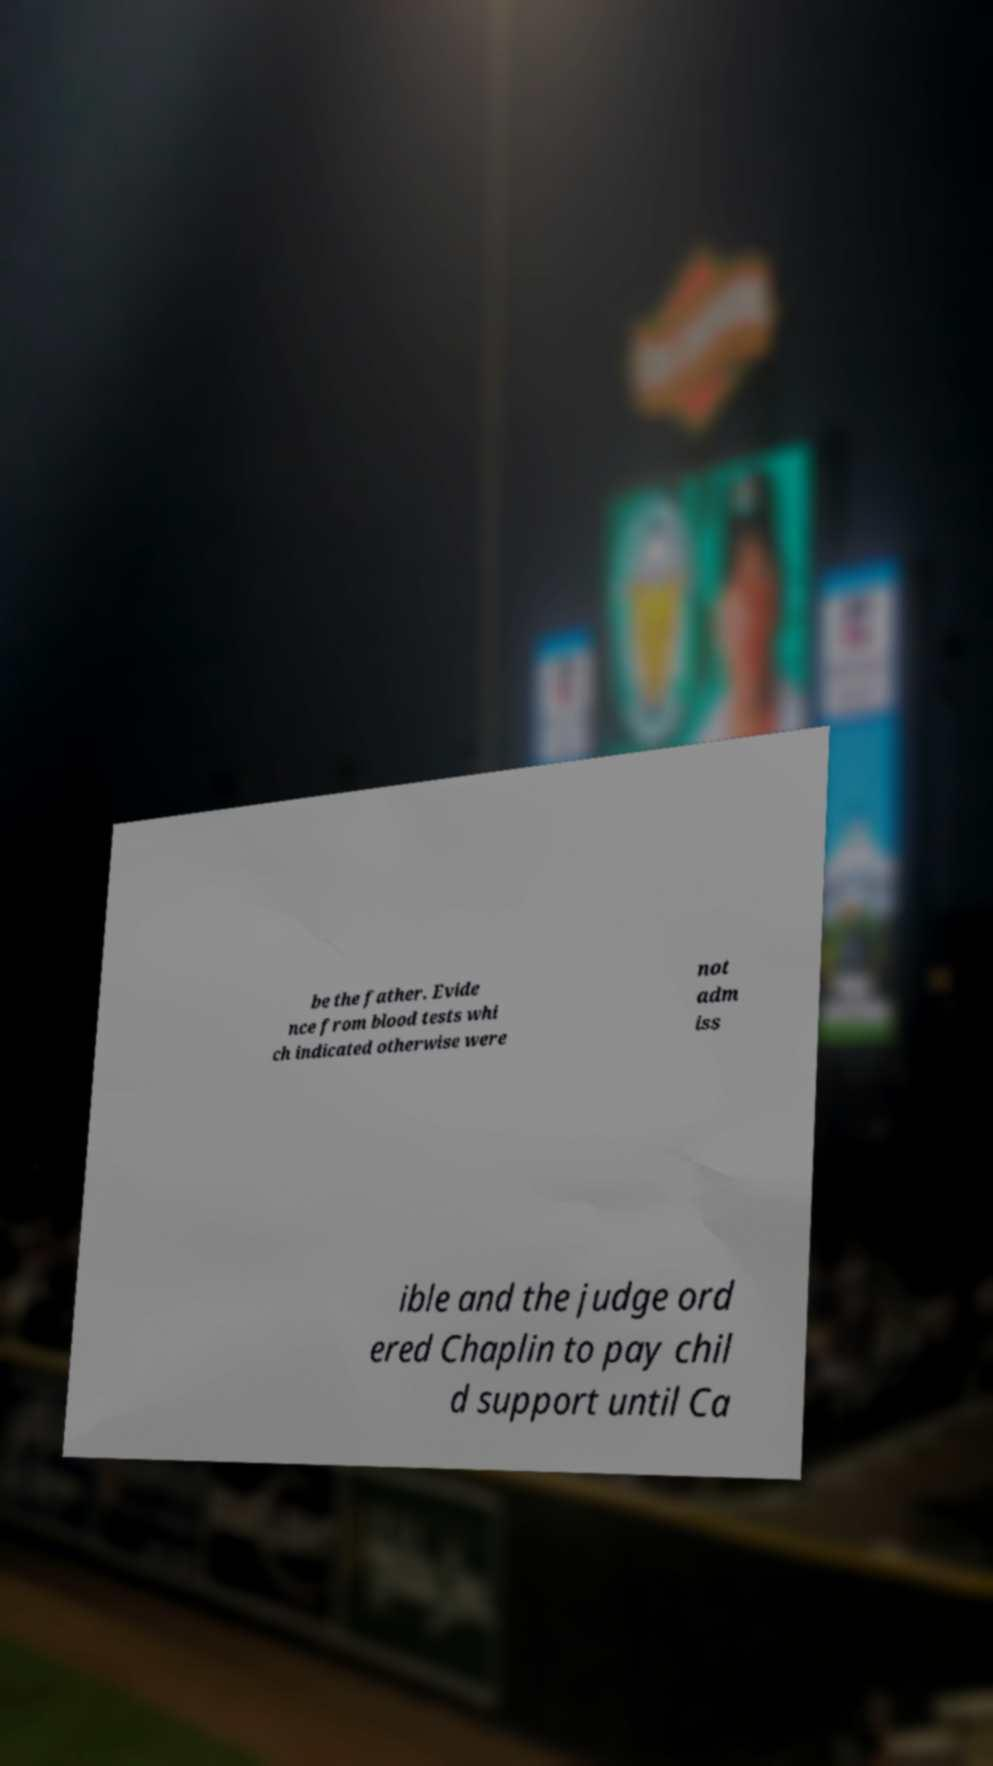Could you extract and type out the text from this image? be the father. Evide nce from blood tests whi ch indicated otherwise were not adm iss ible and the judge ord ered Chaplin to pay chil d support until Ca 